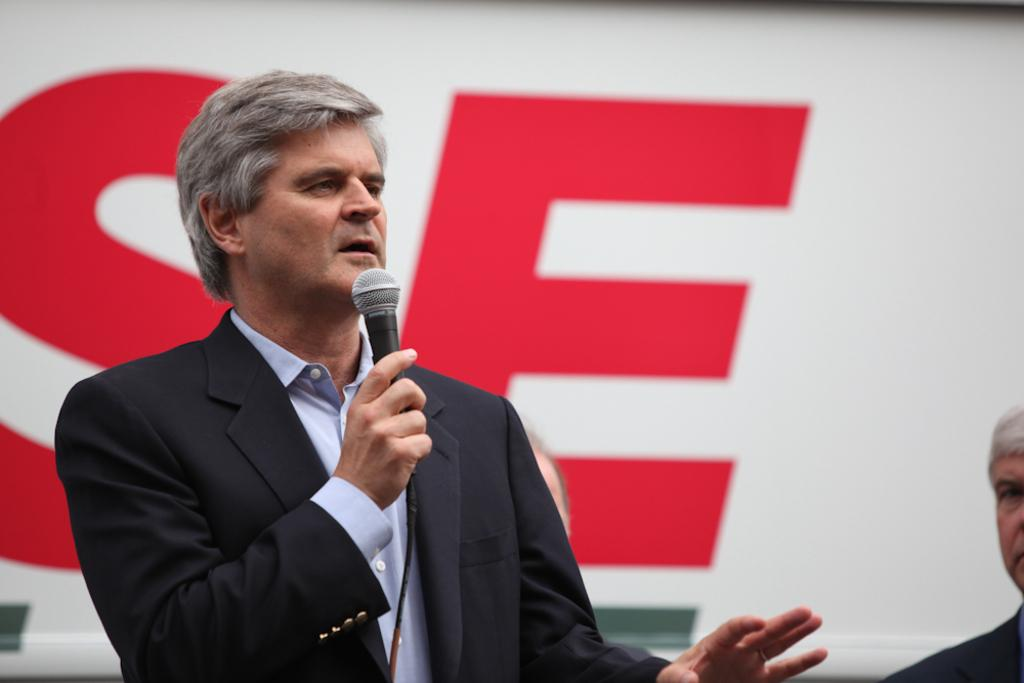What is the main subject of the image? There is a man standing in the center of the image. What is the man holding in the image? The man is holding a microphone. What can be seen in the background of the image? There is a banner in the background of the image. How many fish are swimming in the direction of the lawyer in the image? There are no fish or lawyers present in the image. 